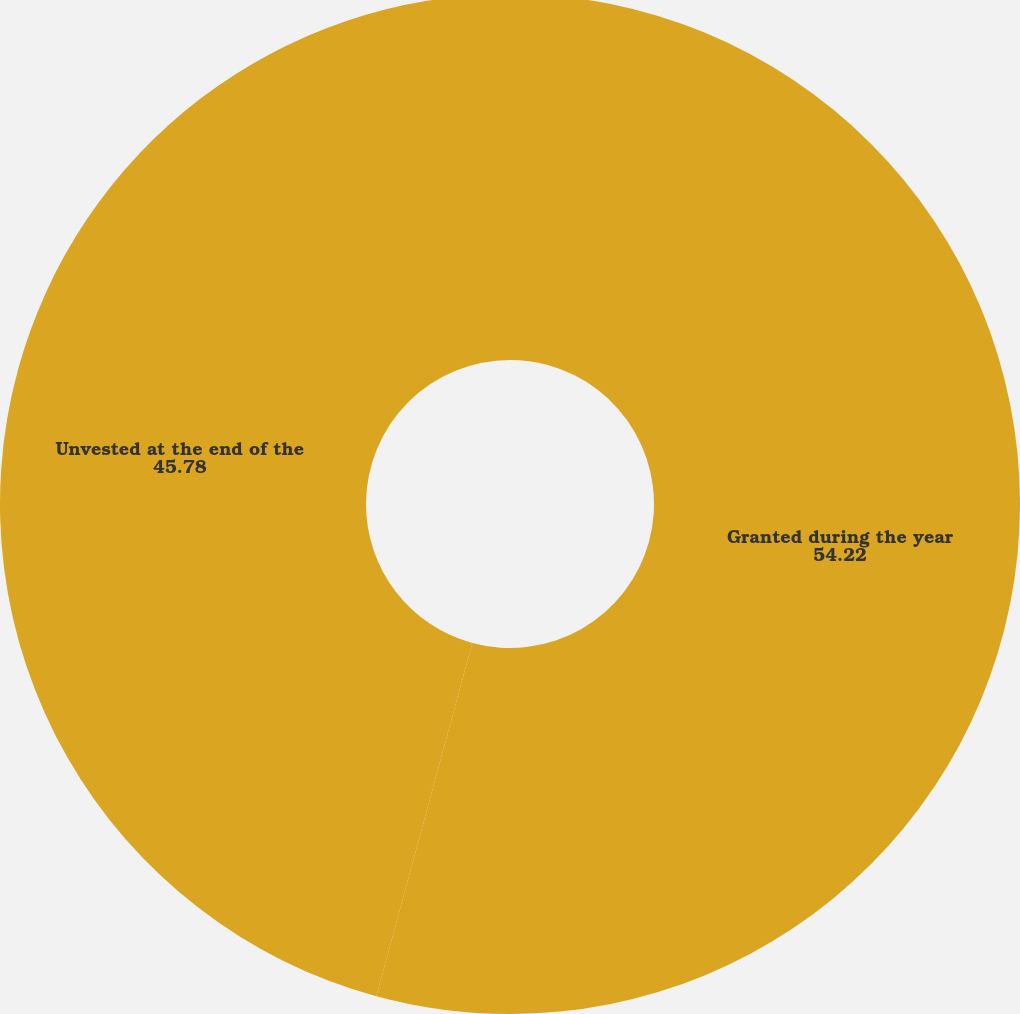Convert chart to OTSL. <chart><loc_0><loc_0><loc_500><loc_500><pie_chart><fcel>Granted during the year<fcel>Unvested at the end of the<nl><fcel>54.22%<fcel>45.78%<nl></chart> 